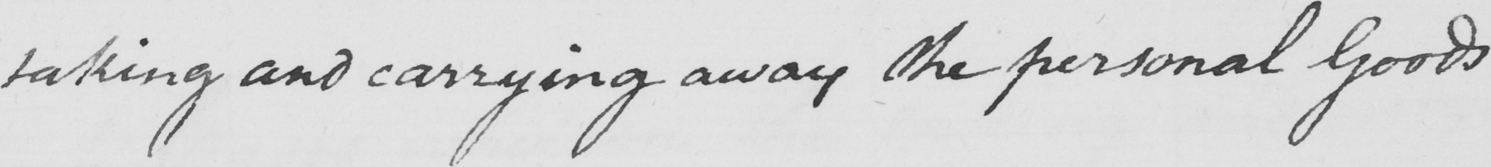What does this handwritten line say? taking and carrying away the personal Goods 